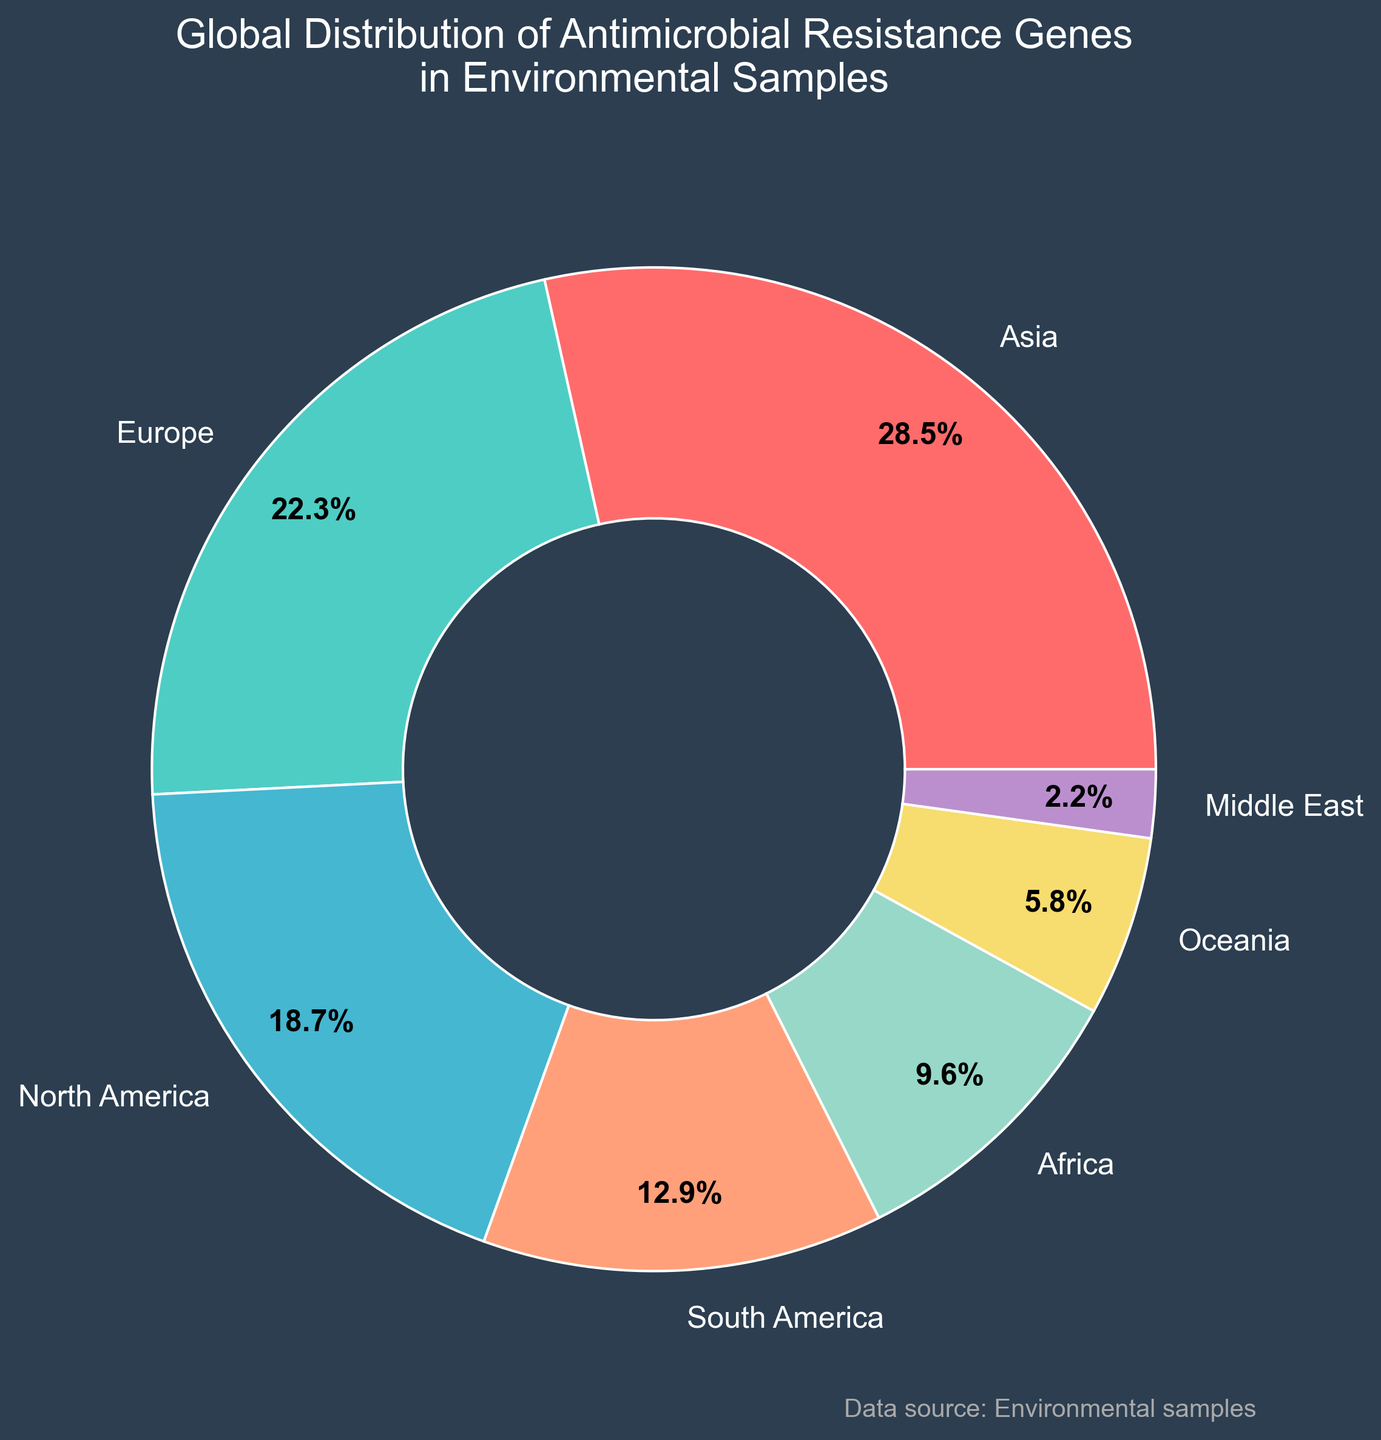Which region has the highest percentage of antimicrobial resistance genes in environmental samples? The pie chart shows the different regions with their respective percentages. Asia has the largest slice.
Answer: Asia What is the total percentage of antimicrobial resistance genes found in Europe and North America combined? From the pie chart, we see Europe has 22.3% and North America has 18.7%. Adding these together: 22.3 + 18.7 = 41.0%
Answer: 41.0% Which regions together make up less than 20% of the global distribution? From the pie chart, the regions with percentages less than 20% are: South America (12.9%), Africa (9.6%), Oceania (5.8%), and the Middle East (2.2%). Summing these up: 12.9 + 9.6 + 5.8 + 2.2 = 30.5%. Only the Middle East and Oceania together are under 20%: 5.8 + 2.2 = 8.0%
Answer: Middle East and Oceania Is the percentage of antimicrobial resistance genes in Asia greater than the sum of all the regions with less than 10%? Asia has 28.5%. Summing up the regions with less than 10%: Africa (9.6%) + Oceania (5.8%) + Middle East (2.2%) = 17.6%. Comparing the two: 28.5% > 17.6%
Answer: Yes What is the percentage difference between the region with the highest percentage and the region with the lowest percentage? From the chart, Asia has the highest at 28.5%, and the Middle East has the lowest at 2.2%. The difference is: 28.5 - 2.2 = 26.3%
Answer: 26.3% Which color represents the region with the second-highest percentage of antimicrobial resistance genes? The pie chart uses specific colors for each region. Europe has the second-highest percentage at 22.3% and is represented by a green color.
Answer: Green (Europe) How many regions have a percentage above the average percentage of all regions? First, find the average percentage: (28.5 + 22.3 + 18.7 + 12.9 + 9.6 + 5.8 + 2.2) / 7 = 100 / 7 ≈ 14.3%. Regions above this percentage are Asia (28.5%), Europe (22.3%), and North America (18.7%). So 3 regions are above the average.
Answer: 3 Which region with a percentage between 5% and 15% occupies the largest portion? From the pie chart, the regions in the 5% to 15% range are South America (12.9%), Africa (9.6%), and Oceania (5.8%). South America has the largest percentage of these.
Answer: South America What would be the new percentage if Oceania's portion was doubled? Oceania's current percentage is 5.8%. Doubling this portion gives: 5.8 * 2 = 11.6%. Adding this back to the total would need subtracting the original: 11.6 - 5.8 = 5.8% as additional, meaning the new total distribution must sum to more than 100%, which is conceptually incorrect as it messes with the pie chart's accuracy in representation. It would become 11.6% in comparison but keep in mind total won't be 100% anymore.
Answer: 11.6% Is the sum of antimicrobial resistance genes in North and South America more or less than that found in Europe? North America has 18.7% and South America has 12.9%. Their sum is 18.7 + 12.9 = 31.6%. Europe has 22.3%. 31.6% is more than 22.3%.
Answer: More 